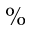<formula> <loc_0><loc_0><loc_500><loc_500>\%</formula> 